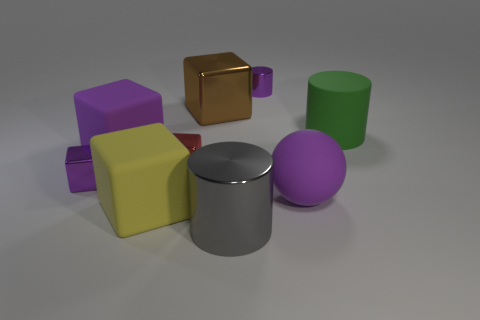How many purple cubes must be subtracted to get 1 purple cubes? 1 Subtract all red blocks. How many blocks are left? 4 Subtract all large purple rubber cubes. How many cubes are left? 4 Subtract all gray blocks. Subtract all yellow cylinders. How many blocks are left? 5 Add 1 tiny blue things. How many objects exist? 10 Subtract all blocks. How many objects are left? 4 Add 6 green matte cylinders. How many green matte cylinders are left? 7 Add 5 big matte cubes. How many big matte cubes exist? 7 Subtract 0 cyan balls. How many objects are left? 9 Subtract all large brown metallic things. Subtract all big green matte things. How many objects are left? 7 